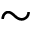Convert formula to latex. <formula><loc_0><loc_0><loc_500><loc_500>\sim</formula> 